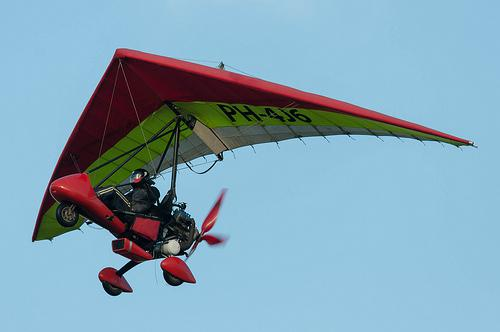Question: how many wheels does the ultralight have?
Choices:
A. Four.
B. Three.
C. Two.
D. Eight.
Answer with the letter. Answer: B Question: what is written on the wing?
Choices:
A. Ph-434.
B. Thx-1138.
C. PH-4J6.
D. T-1000.
Answer with the letter. Answer: C Question: where is the propeller?
Choices:
A. In front of the man.
B. Behind the man.
C. To the left of the man.
D. To the right of the man.
Answer with the letter. Answer: B 